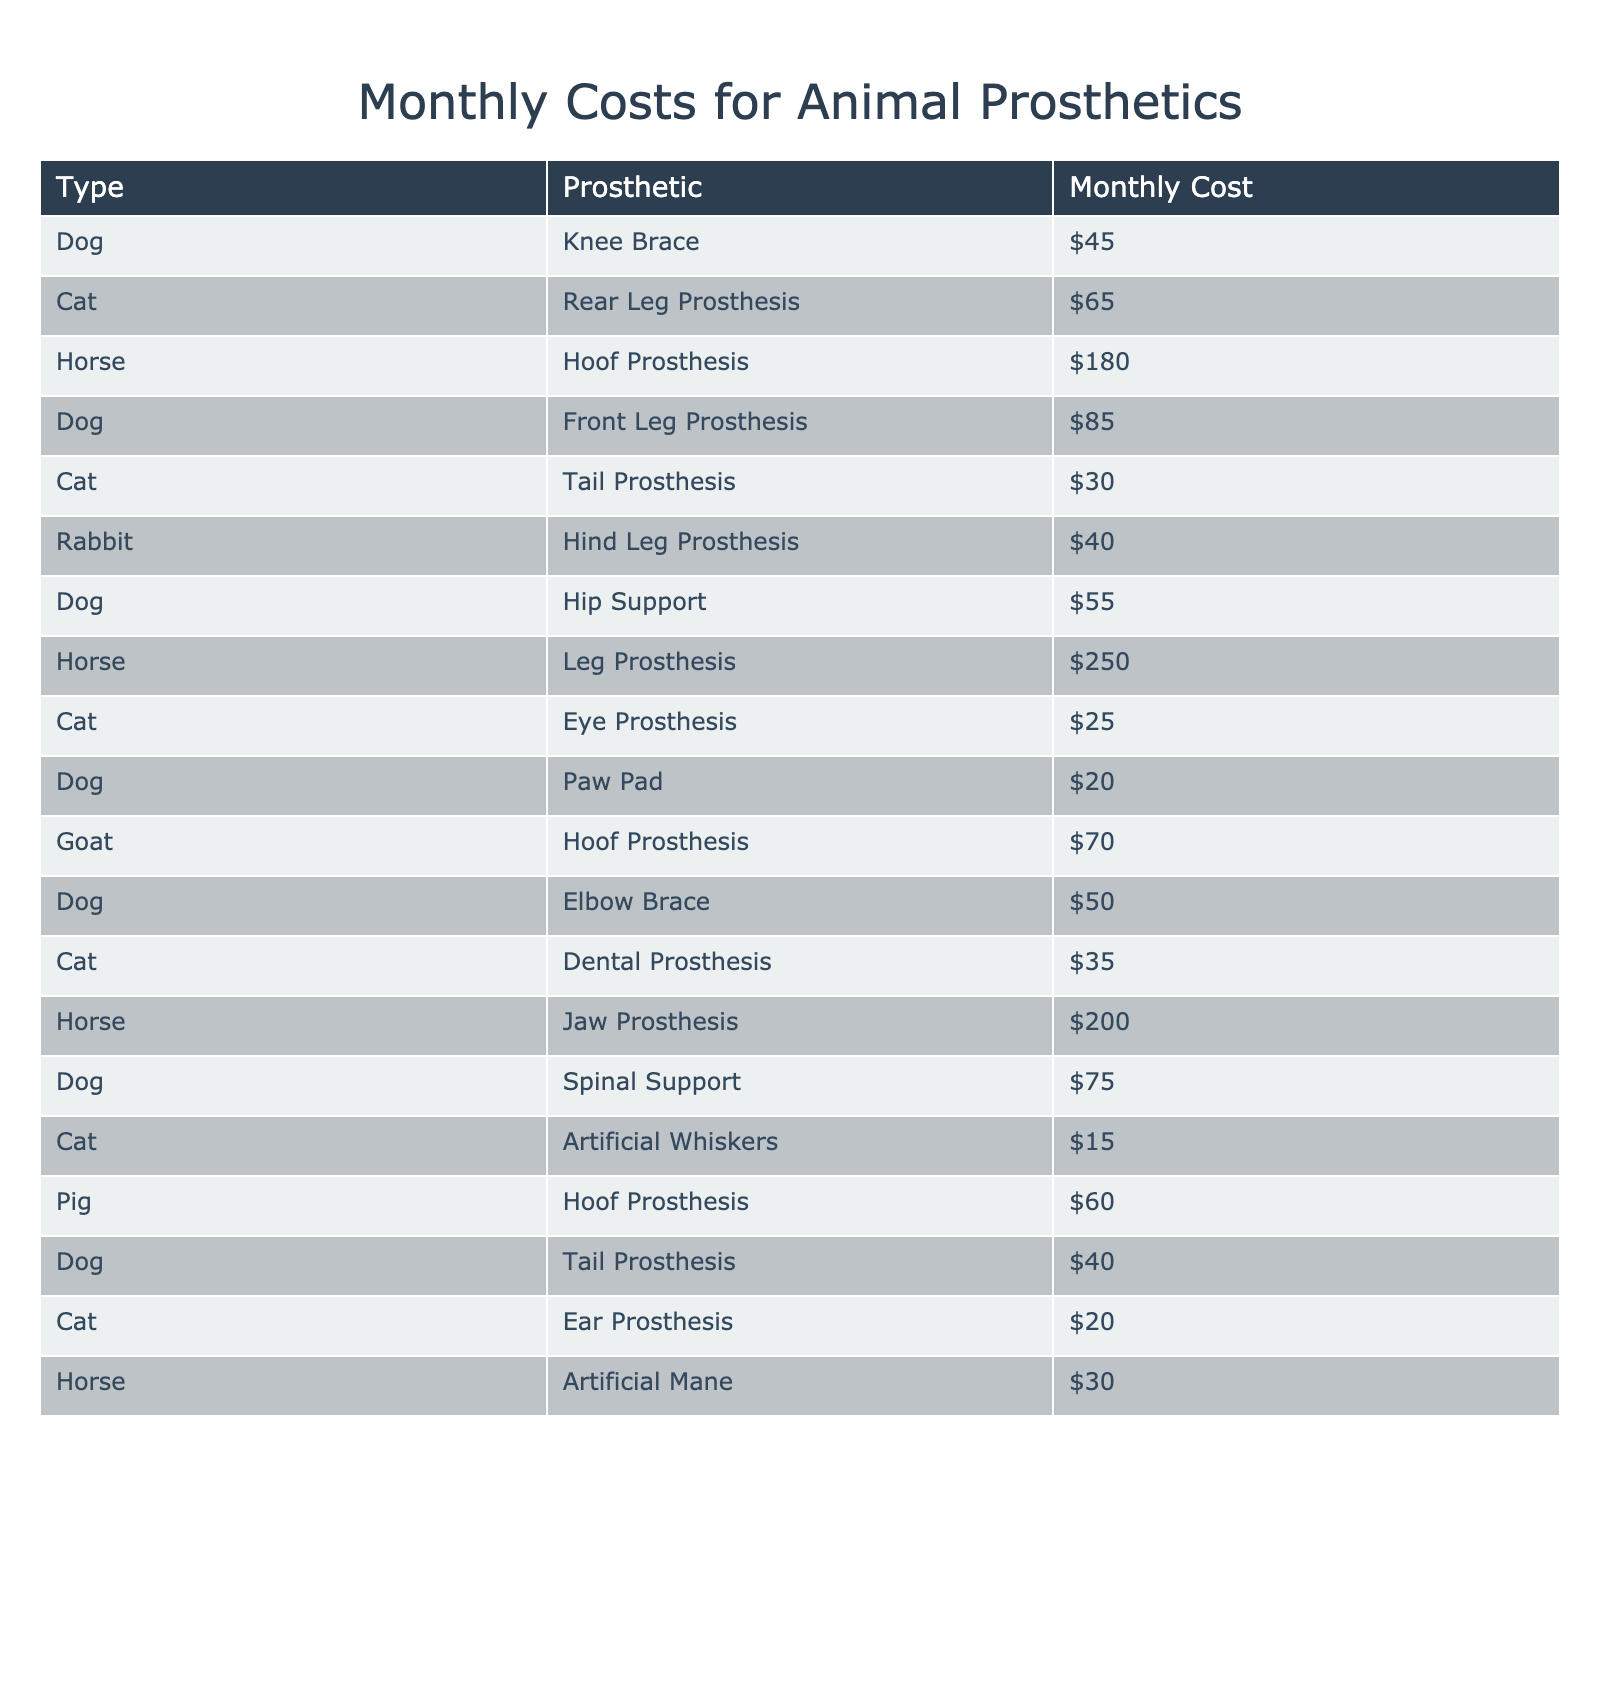What is the monthly cost of a hind leg prosthesis for a rabbit? According to the table, a hind leg prosthesis for a rabbit has a monthly cost of $40.
Answer: $40 Which animal has the highest monthly cost for a prosthetic? The table shows that the horse's leg prosthesis costs $250, which is the highest among all listed.
Answer: $250 What is the average monthly cost for dog prosthetics? The monthly costs for dog prosthetics are $45 (Knee Brace), $85 (Front Leg Prosthesis), $55 (Hip Support), $20 (Paw Pad), $50 (Elbow Brace), $75 (Spinal Support), and $40 (Tail Prosthesis). Sum these costs: 45 + 85 + 55 + 20 + 50 + 75 + 40 = 370. There are 7 dog prosthetics, so the average is 370/7 ≈ 52.86.
Answer: Approximately $52.86 Is there a prosthetic for pigs listed in the table? The table includes a monthly cost for a pig hoof prosthesis, indicating that there is indeed a prosthetic for pigs listed.
Answer: Yes What is the total monthly cost for all the cat prosthetics combined? The monthly costs for cat prosthetics are $65 (Rear Leg Prosthesis), $30 (Tail Prosthesis), $25 (Eye Prosthesis), $35 (Dental Prosthesis), $15 (Artificial Whiskers), $20 (Ear Prosthesis). Summing these gives: 65 + 30 + 25 + 35 + 15 + 20 = 190.
Answer: $190 How much more expensive is a horse jaw prosthesis compared to a cat eye prosthesis? A horse jaw prosthesis costs $200, while a cat eye prosthesis costs $25. The difference is 200 - 25 = 175.
Answer: $175 Are the total costs of a cat's dental and rear leg prosthetic less than $100? The cat's dental prosthesis costs $35, and the rear leg prosthesis costs $65. Together they total: 35 + 65 = 100, which is exactly $100. Therefore, the costs are not less than $100.
Answer: No Which animal has the lowest monthly prosthetic cost and what is it? Looking at the table, the cat's artificial whiskers has the lowest monthly cost at $15.
Answer: Cat's artificial whiskers at $15 How does the monthly cost of a horse hoof prosthesis compare to a dog knee brace? The monthly cost of a horse hoof prosthesis is $180, while the dog knee brace costs $45. The difference is 180 - 45 = 135. Thus, the horse hoof prosthesis is $135 more expensive.
Answer: $135 more expensive What is the total monthly cost of all types of prosthetics listed? To find the total, we need to add together all the individual monthly costs from the table. The total sum is 45 + 65 + 180 + 85 + 30 + 40 + 55 + 250 + 25 + 20 + 70 + 50 + 35 + 200 + 75 + 15 + 60 + 40 + 20 + 30 = 855.
Answer: $855 